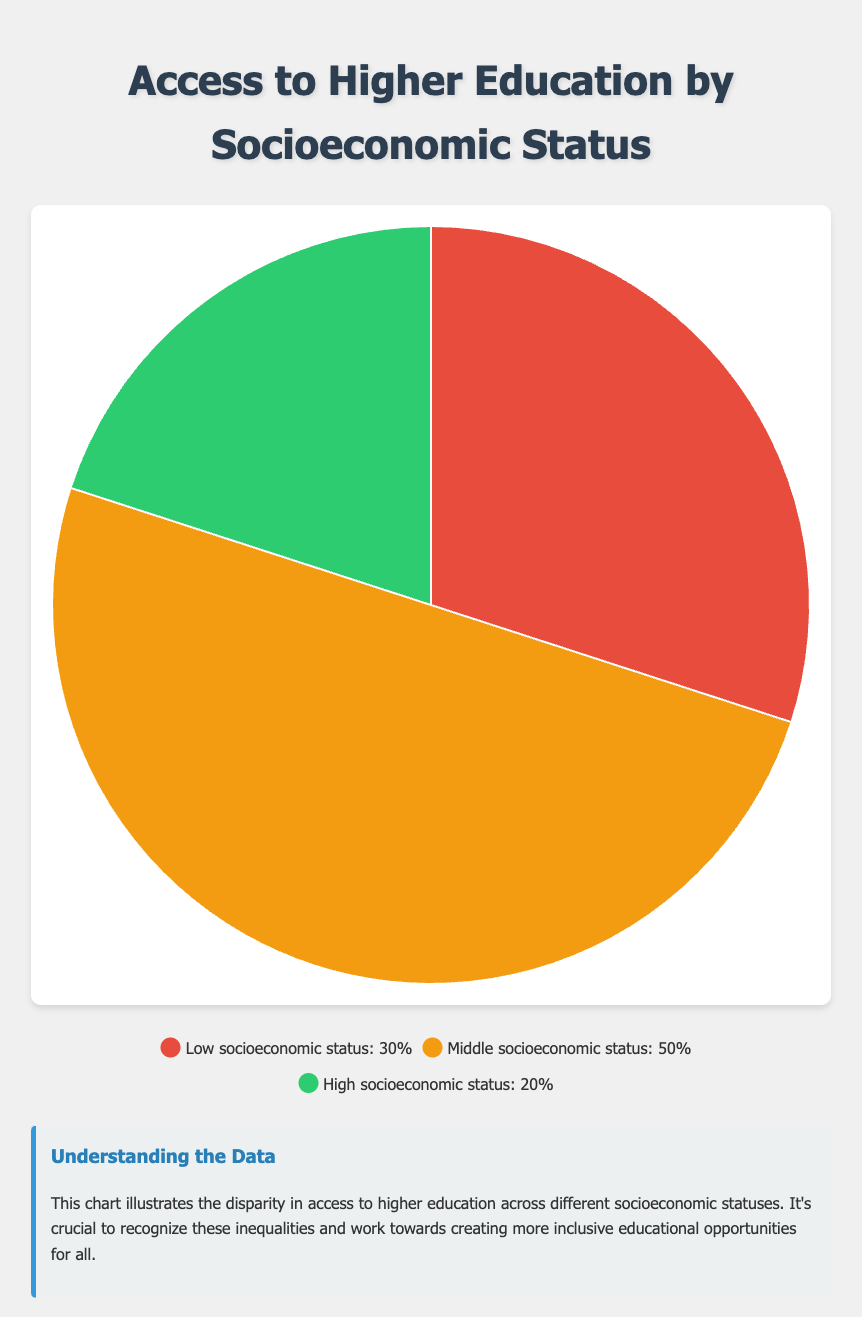What's the total percentage for access to higher education for individuals from low and middle socioeconomic status combined? The combined total is achieved by summing the percentages of both groups: 30% (low) + 50% (middle) = 80%
Answer: 80% Which socioeconomic status category has the highest access to higher education? From the pie chart, the category "Middle socioeconomic status" has the highest percentage slice at 50%.
Answer: Middle socioeconomic status How much more access to higher education do individuals from middle socioeconomic status have compared to high socioeconomic status? The difference in percentage points between middle and high socioeconomic statuses is 50% - 20% = 30%.
Answer: 30% What portion of access to higher education is represented by individuals from low and high socioeconomic statuses combined? Summing the percentages for low and high socioeconomic statuses gives 30% + 20% = 50%.
Answer: 50% Which color represents the category with the least access to higher education? The category "High socioeconomic status," having the lowest percentage (20%), is represented by the color green.
Answer: green How many times greater is the access percentage for middle socioeconomic status compared to high socioeconomic status? The access percentage for middle (50%) divided by the access percentage for high (20%) is 50% / 20% = 2.5 times greater.
Answer: 2.5 times If we combine the access percentages for middle and high socioeconomic statuses, what is the combined average percentage? The combined average is calculated by summing the percentages and dividing by the number of groups: (50% + 20%) / 2 = 35%.
Answer: 35% Which category has a red-colored representation in the pie chart? The "Low socioeconomic status" category is represented by the red color.
Answer: Low socioeconomic status What's the difference in access percentages between the middle and low socioeconomic statuses? The difference is calculated as 50% (middle) - 30% (low) = 20%.
Answer: 20% If the total population of individuals accessing higher education is 10,000, how many individuals from middle socioeconomic status access higher education? The number of individuals from middle socioeconomic status is calculated as 50% of 10,000 which is 0.50 * 10,000 = 5,000 individuals.
Answer: 5,000 